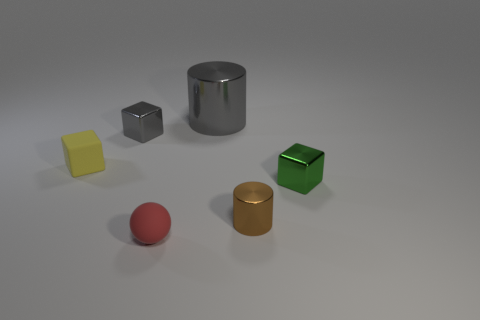Is there anything else that is the same size as the gray cylinder?
Offer a very short reply. No. Are there any cubes made of the same material as the tiny red thing?
Your answer should be very brief. Yes. What material is the gray thing in front of the gray shiny thing to the right of the red matte object?
Give a very brief answer. Metal. What size is the gray metallic object to the right of the tiny red rubber ball?
Your response must be concise. Large. Does the small rubber ball have the same color as the tiny shiny block behind the tiny yellow block?
Give a very brief answer. No. Are there any small shiny objects of the same color as the big metal object?
Your answer should be very brief. Yes. Is the material of the small red thing the same as the small object to the right of the brown thing?
Your answer should be very brief. No. What number of tiny objects are green metallic objects or red things?
Make the answer very short. 2. What material is the other thing that is the same color as the big shiny object?
Give a very brief answer. Metal. Is the number of metal blocks less than the number of tiny blocks?
Make the answer very short. Yes. 